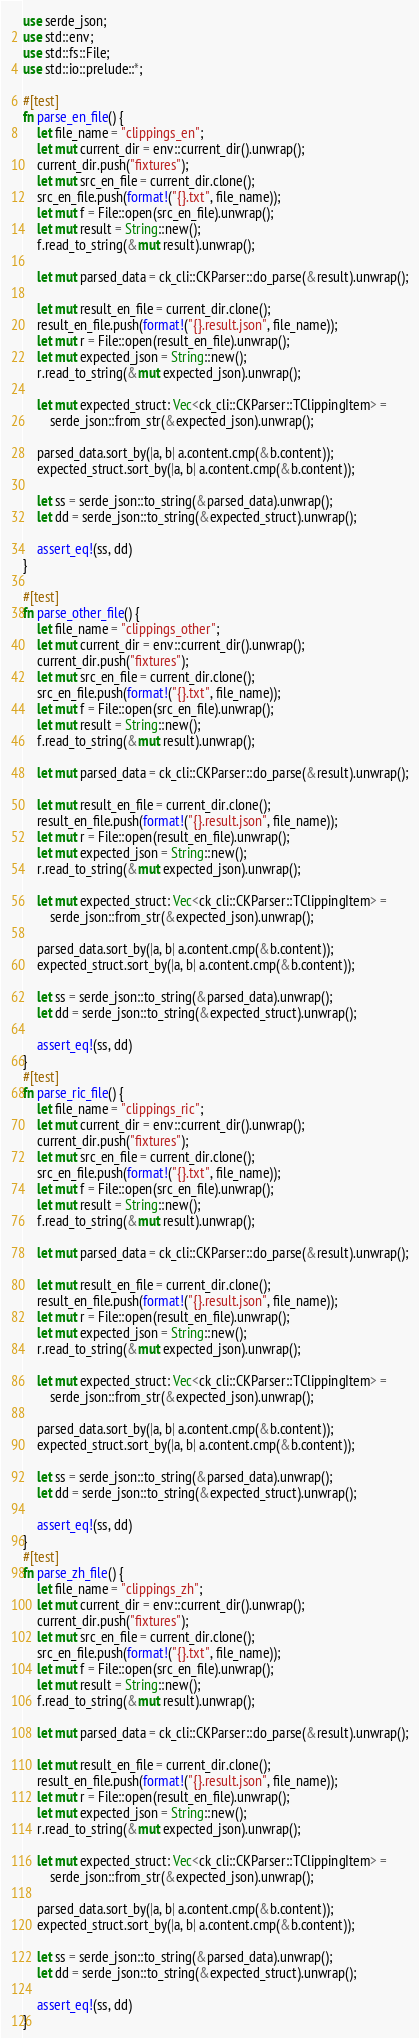Convert code to text. <code><loc_0><loc_0><loc_500><loc_500><_Rust_>use serde_json;
use std::env;
use std::fs::File;
use std::io::prelude::*;

#[test]
fn parse_en_file() {
    let file_name = "clippings_en";
    let mut current_dir = env::current_dir().unwrap();
    current_dir.push("fixtures");
    let mut src_en_file = current_dir.clone();
    src_en_file.push(format!("{}.txt", file_name));
    let mut f = File::open(src_en_file).unwrap();
    let mut result = String::new();
    f.read_to_string(&mut result).unwrap();

    let mut parsed_data = ck_cli::CKParser::do_parse(&result).unwrap();

    let mut result_en_file = current_dir.clone();
    result_en_file.push(format!("{}.result.json", file_name));
    let mut r = File::open(result_en_file).unwrap();
    let mut expected_json = String::new();
    r.read_to_string(&mut expected_json).unwrap();

    let mut expected_struct: Vec<ck_cli::CKParser::TClippingItem> =
        serde_json::from_str(&expected_json).unwrap();

    parsed_data.sort_by(|a, b| a.content.cmp(&b.content));
    expected_struct.sort_by(|a, b| a.content.cmp(&b.content));

    let ss = serde_json::to_string(&parsed_data).unwrap();
    let dd = serde_json::to_string(&expected_struct).unwrap();

    assert_eq!(ss, dd)
}

#[test]
fn parse_other_file() {
    let file_name = "clippings_other";
    let mut current_dir = env::current_dir().unwrap();
    current_dir.push("fixtures");
    let mut src_en_file = current_dir.clone();
    src_en_file.push(format!("{}.txt", file_name));
    let mut f = File::open(src_en_file).unwrap();
    let mut result = String::new();
    f.read_to_string(&mut result).unwrap();

    let mut parsed_data = ck_cli::CKParser::do_parse(&result).unwrap();

    let mut result_en_file = current_dir.clone();
    result_en_file.push(format!("{}.result.json", file_name));
    let mut r = File::open(result_en_file).unwrap();
    let mut expected_json = String::new();
    r.read_to_string(&mut expected_json).unwrap();

    let mut expected_struct: Vec<ck_cli::CKParser::TClippingItem> =
        serde_json::from_str(&expected_json).unwrap();

    parsed_data.sort_by(|a, b| a.content.cmp(&b.content));
    expected_struct.sort_by(|a, b| a.content.cmp(&b.content));

    let ss = serde_json::to_string(&parsed_data).unwrap();
    let dd = serde_json::to_string(&expected_struct).unwrap();

    assert_eq!(ss, dd)
}
#[test]
fn parse_ric_file() {
    let file_name = "clippings_ric";
    let mut current_dir = env::current_dir().unwrap();
    current_dir.push("fixtures");
    let mut src_en_file = current_dir.clone();
    src_en_file.push(format!("{}.txt", file_name));
    let mut f = File::open(src_en_file).unwrap();
    let mut result = String::new();
    f.read_to_string(&mut result).unwrap();

    let mut parsed_data = ck_cli::CKParser::do_parse(&result).unwrap();

    let mut result_en_file = current_dir.clone();
    result_en_file.push(format!("{}.result.json", file_name));
    let mut r = File::open(result_en_file).unwrap();
    let mut expected_json = String::new();
    r.read_to_string(&mut expected_json).unwrap();

    let mut expected_struct: Vec<ck_cli::CKParser::TClippingItem> =
        serde_json::from_str(&expected_json).unwrap();

    parsed_data.sort_by(|a, b| a.content.cmp(&b.content));
    expected_struct.sort_by(|a, b| a.content.cmp(&b.content));

    let ss = serde_json::to_string(&parsed_data).unwrap();
    let dd = serde_json::to_string(&expected_struct).unwrap();

    assert_eq!(ss, dd)
}
#[test]
fn parse_zh_file() {
    let file_name = "clippings_zh";
    let mut current_dir = env::current_dir().unwrap();
    current_dir.push("fixtures");
    let mut src_en_file = current_dir.clone();
    src_en_file.push(format!("{}.txt", file_name));
    let mut f = File::open(src_en_file).unwrap();
    let mut result = String::new();
    f.read_to_string(&mut result).unwrap();

    let mut parsed_data = ck_cli::CKParser::do_parse(&result).unwrap();

    let mut result_en_file = current_dir.clone();
    result_en_file.push(format!("{}.result.json", file_name));
    let mut r = File::open(result_en_file).unwrap();
    let mut expected_json = String::new();
    r.read_to_string(&mut expected_json).unwrap();

    let mut expected_struct: Vec<ck_cli::CKParser::TClippingItem> =
        serde_json::from_str(&expected_json).unwrap();

    parsed_data.sort_by(|a, b| a.content.cmp(&b.content));
    expected_struct.sort_by(|a, b| a.content.cmp(&b.content));

    let ss = serde_json::to_string(&parsed_data).unwrap();
    let dd = serde_json::to_string(&expected_struct).unwrap();

    assert_eq!(ss, dd)
}
</code> 